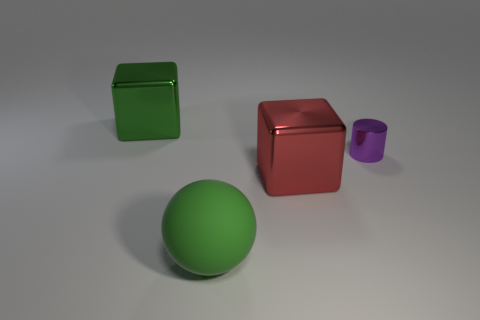Are there any other things that have the same size as the purple cylinder?
Give a very brief answer. No. What color is the other large shiny object that is the same shape as the big red thing?
Your answer should be very brief. Green. Is there anything else that has the same shape as the green metallic thing?
Provide a short and direct response. Yes. Is the number of metal cylinders greater than the number of large blocks?
Offer a terse response. No. What number of other objects are the same material as the red object?
Provide a short and direct response. 2. What shape is the metallic object that is in front of the object right of the big metallic cube in front of the large green metallic block?
Provide a short and direct response. Cube. Are there fewer green objects that are behind the red metallic cube than large red shiny things behind the tiny cylinder?
Your response must be concise. No. Are there any other large objects of the same color as the large rubber object?
Keep it short and to the point. Yes. Is the material of the tiny cylinder the same as the green thing that is in front of the green metal object?
Your response must be concise. No. Is there a large red object that is in front of the object to the right of the red cube?
Give a very brief answer. Yes. 